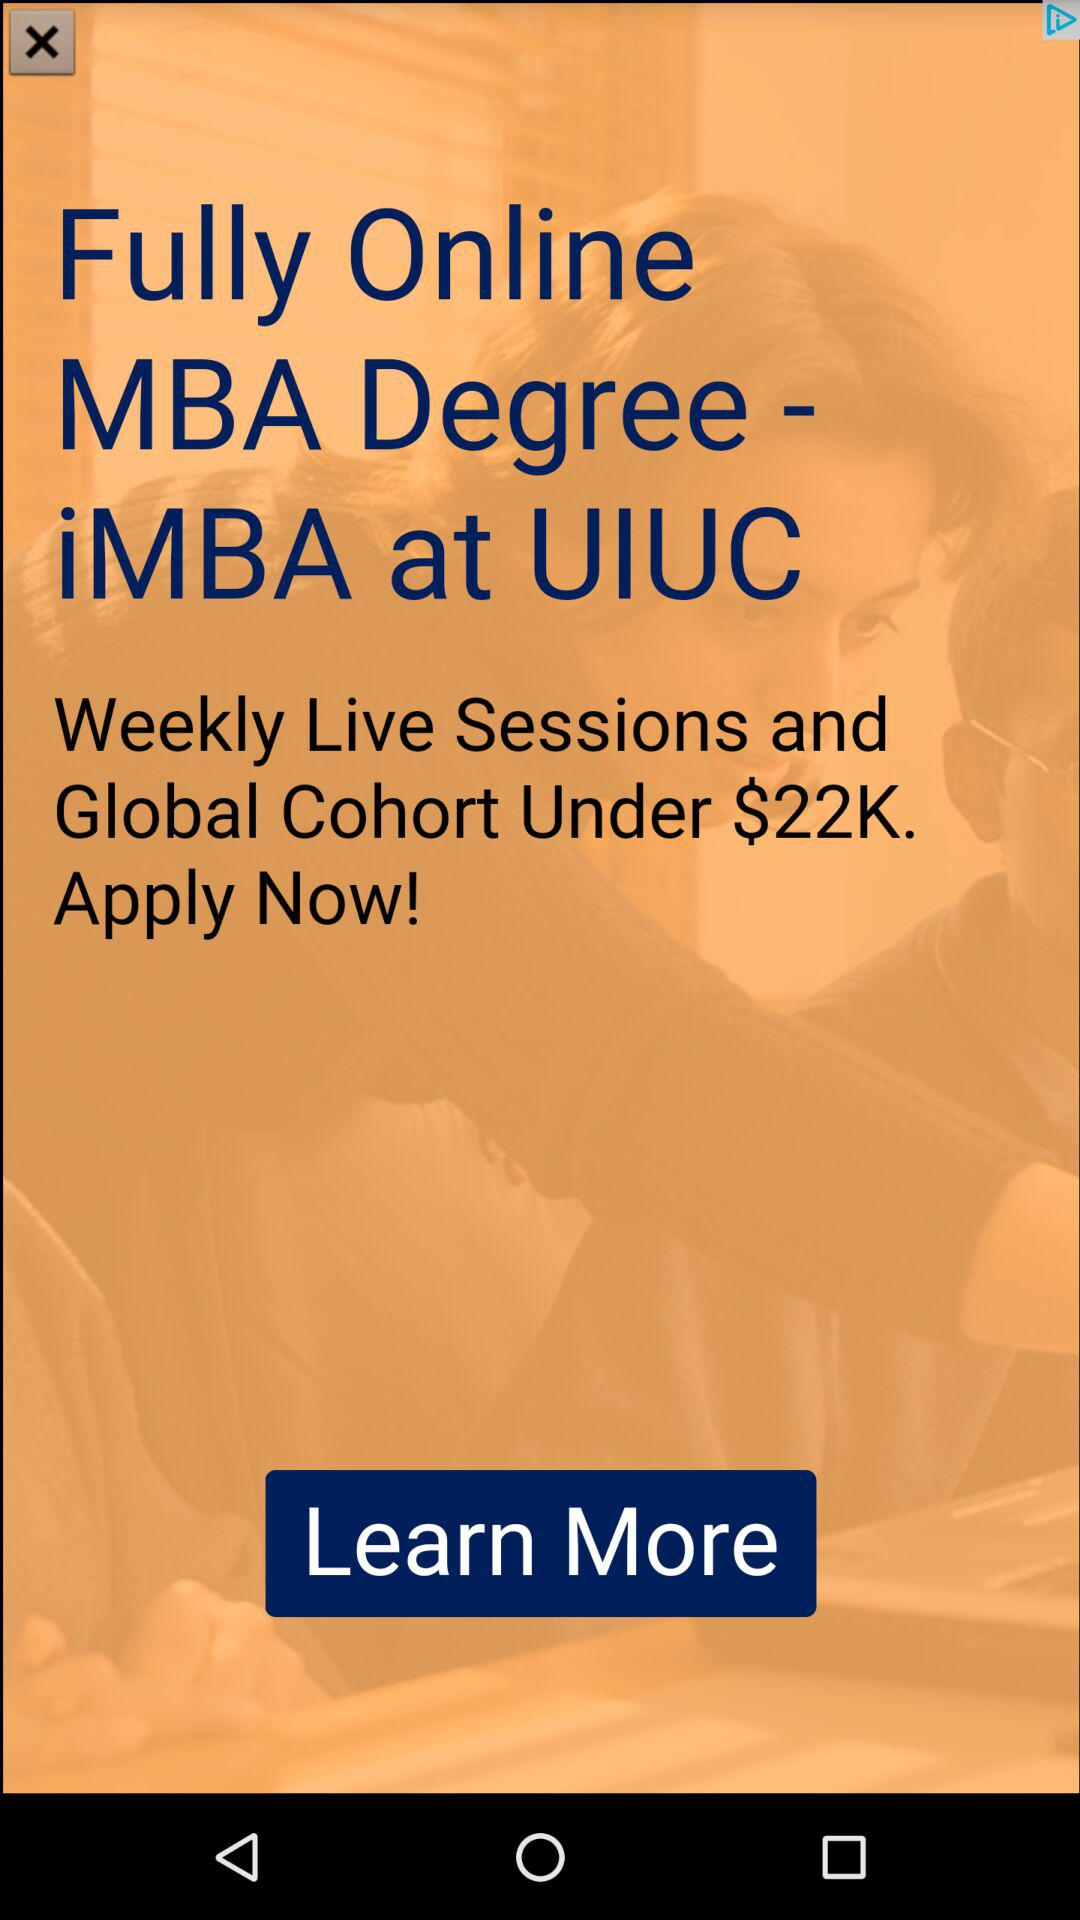What is the price for the weekly live session? The price is under $22,000. 